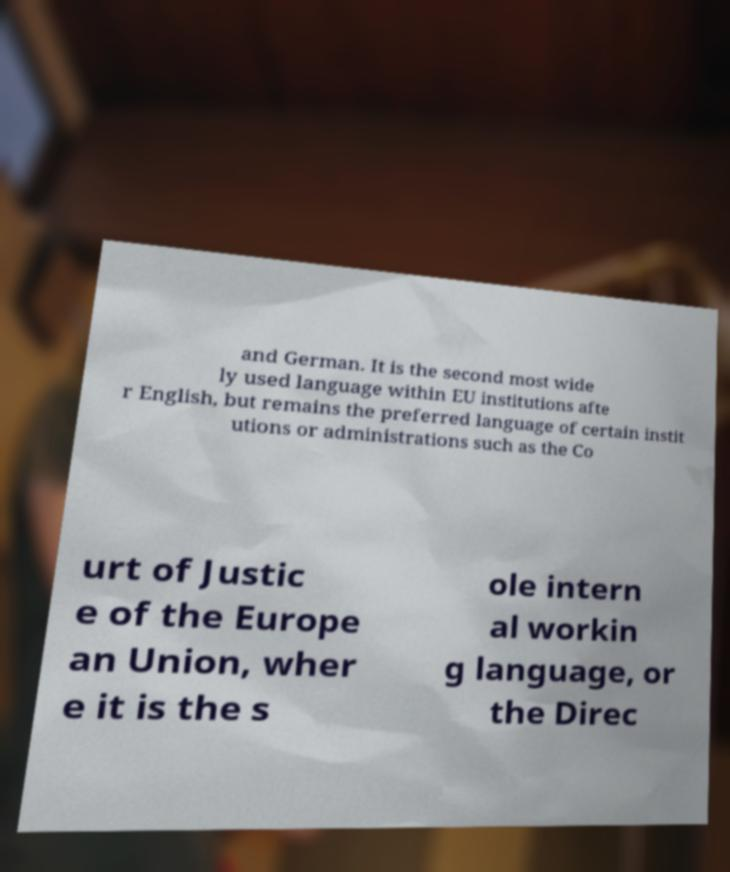Could you assist in decoding the text presented in this image and type it out clearly? and German. It is the second most wide ly used language within EU institutions afte r English, but remains the preferred language of certain instit utions or administrations such as the Co urt of Justic e of the Europe an Union, wher e it is the s ole intern al workin g language, or the Direc 